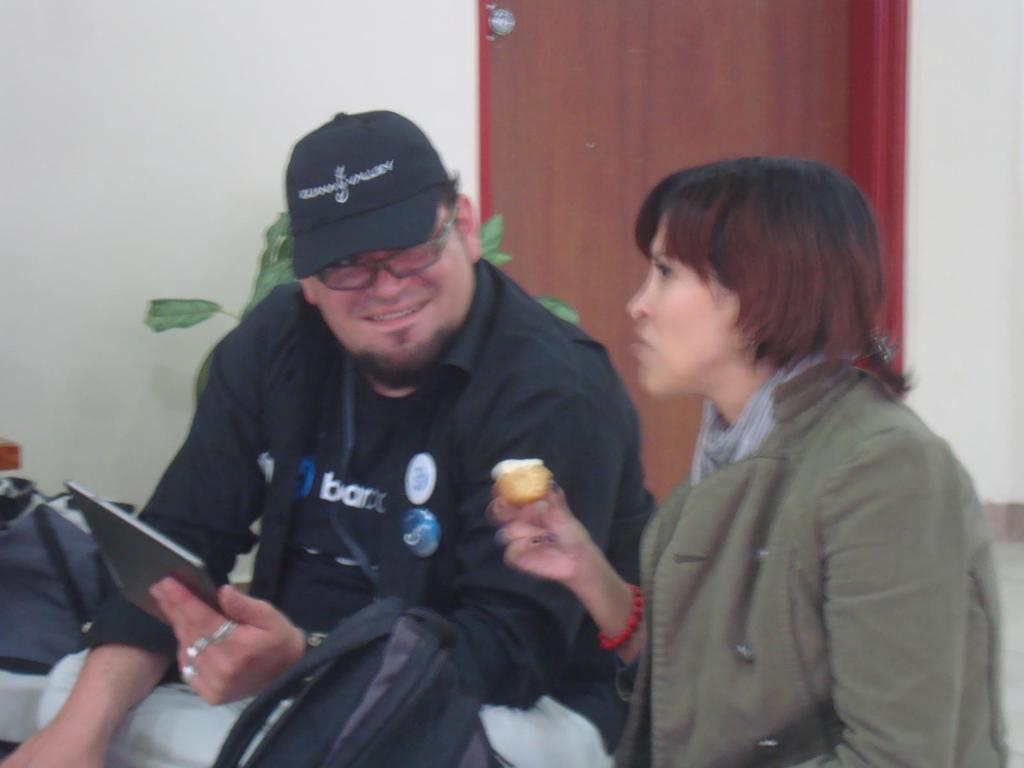Could you give a brief overview of what you see in this image? In this picture I can see a woman and a man holding a tablet in his hand and I can see a woman holding some food in her hand and I can see couple of bags and I can see a plant,door and a wall in the background. 